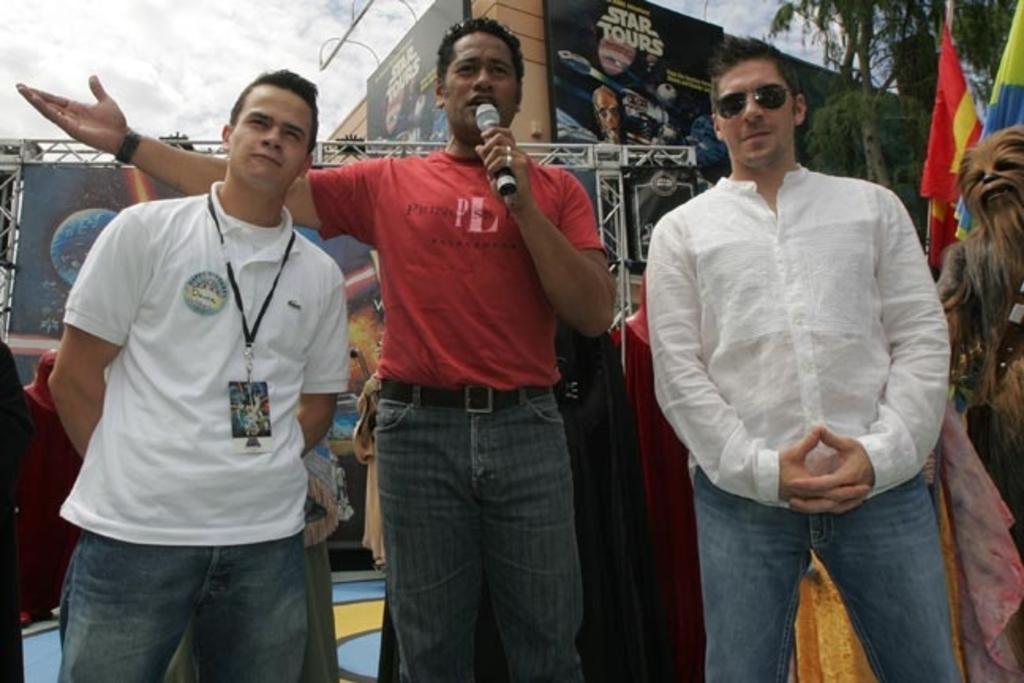In one or two sentences, can you explain what this image depicts? This picture describes about group of people, in the middle of the image we can see a man, he wore a red color T-shirt and he is holding a microphone, in the background we can see few hoardings, metal rods, flags and few trees. 